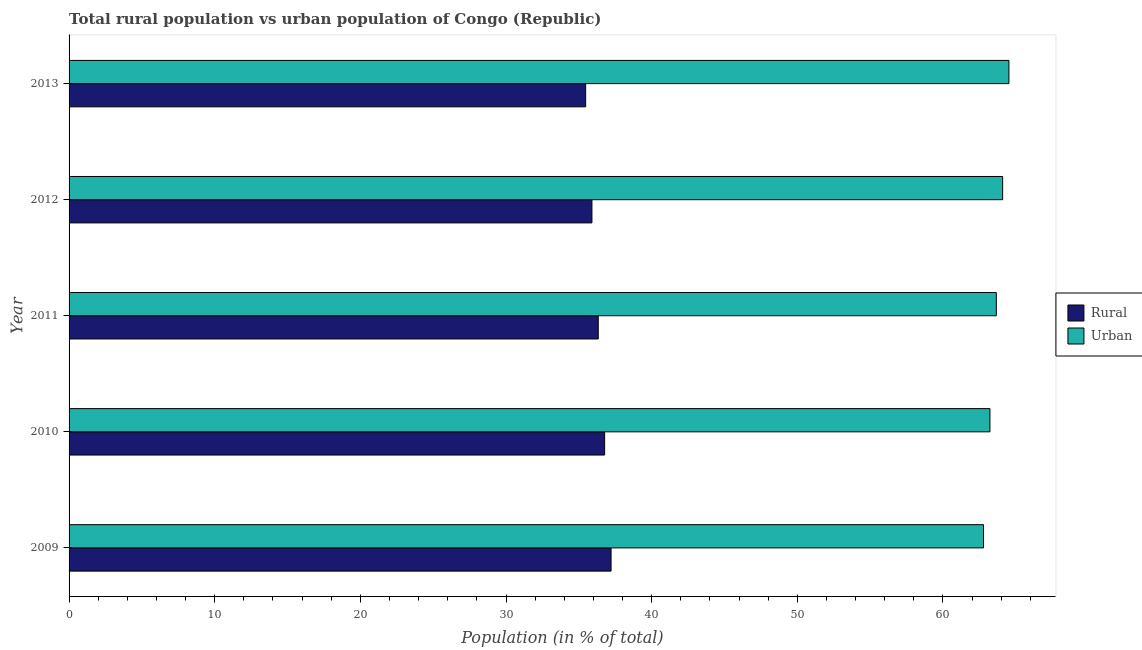How many different coloured bars are there?
Offer a terse response. 2. How many groups of bars are there?
Your answer should be compact. 5. How many bars are there on the 3rd tick from the bottom?
Keep it short and to the point. 2. What is the label of the 4th group of bars from the top?
Give a very brief answer. 2010. What is the rural population in 2013?
Your response must be concise. 35.47. Across all years, what is the maximum urban population?
Your response must be concise. 64.53. Across all years, what is the minimum urban population?
Offer a terse response. 62.79. In which year was the urban population maximum?
Make the answer very short. 2013. What is the total urban population in the graph?
Provide a short and direct response. 318.31. What is the difference between the urban population in 2009 and that in 2011?
Make the answer very short. -0.88. What is the difference between the urban population in 2009 and the rural population in 2013?
Your answer should be very brief. 27.32. What is the average rural population per year?
Give a very brief answer. 36.34. In the year 2012, what is the difference between the urban population and rural population?
Ensure brevity in your answer.  28.2. In how many years, is the urban population greater than 2 %?
Your answer should be very brief. 5. What is the ratio of the rural population in 2010 to that in 2013?
Your response must be concise. 1.04. Is the rural population in 2009 less than that in 2010?
Your answer should be compact. No. Is the difference between the rural population in 2009 and 2010 greater than the difference between the urban population in 2009 and 2010?
Your answer should be very brief. Yes. What is the difference between the highest and the second highest urban population?
Offer a very short reply. 0.43. What does the 1st bar from the top in 2013 represents?
Make the answer very short. Urban. What does the 2nd bar from the bottom in 2010 represents?
Make the answer very short. Urban. How many bars are there?
Give a very brief answer. 10. What is the difference between two consecutive major ticks on the X-axis?
Offer a very short reply. 10. Does the graph contain any zero values?
Your answer should be very brief. No. Does the graph contain grids?
Your answer should be very brief. No. How many legend labels are there?
Your answer should be compact. 2. How are the legend labels stacked?
Offer a very short reply. Vertical. What is the title of the graph?
Make the answer very short. Total rural population vs urban population of Congo (Republic). Does "Non-pregnant women" appear as one of the legend labels in the graph?
Your answer should be very brief. No. What is the label or title of the X-axis?
Give a very brief answer. Population (in % of total). What is the label or title of the Y-axis?
Keep it short and to the point. Year. What is the Population (in % of total) in Rural in 2009?
Ensure brevity in your answer.  37.21. What is the Population (in % of total) in Urban in 2009?
Offer a very short reply. 62.79. What is the Population (in % of total) of Rural in 2010?
Your answer should be very brief. 36.77. What is the Population (in % of total) of Urban in 2010?
Provide a succinct answer. 63.23. What is the Population (in % of total) of Rural in 2011?
Your answer should be very brief. 36.33. What is the Population (in % of total) in Urban in 2011?
Offer a terse response. 63.67. What is the Population (in % of total) of Rural in 2012?
Make the answer very short. 35.9. What is the Population (in % of total) in Urban in 2012?
Your answer should be very brief. 64.1. What is the Population (in % of total) in Rural in 2013?
Your answer should be compact. 35.47. What is the Population (in % of total) in Urban in 2013?
Provide a succinct answer. 64.53. Across all years, what is the maximum Population (in % of total) of Rural?
Offer a terse response. 37.21. Across all years, what is the maximum Population (in % of total) of Urban?
Ensure brevity in your answer.  64.53. Across all years, what is the minimum Population (in % of total) of Rural?
Ensure brevity in your answer.  35.47. Across all years, what is the minimum Population (in % of total) in Urban?
Offer a terse response. 62.79. What is the total Population (in % of total) in Rural in the graph?
Offer a very short reply. 181.69. What is the total Population (in % of total) in Urban in the graph?
Offer a very short reply. 318.31. What is the difference between the Population (in % of total) of Rural in 2009 and that in 2010?
Ensure brevity in your answer.  0.44. What is the difference between the Population (in % of total) in Urban in 2009 and that in 2010?
Offer a terse response. -0.44. What is the difference between the Population (in % of total) of Urban in 2009 and that in 2011?
Your response must be concise. -0.88. What is the difference between the Population (in % of total) in Rural in 2009 and that in 2012?
Your answer should be very brief. 1.31. What is the difference between the Population (in % of total) of Urban in 2009 and that in 2012?
Your answer should be very brief. -1.31. What is the difference between the Population (in % of total) of Rural in 2009 and that in 2013?
Your answer should be very brief. 1.75. What is the difference between the Population (in % of total) in Urban in 2009 and that in 2013?
Offer a terse response. -1.75. What is the difference between the Population (in % of total) of Rural in 2010 and that in 2011?
Ensure brevity in your answer.  0.44. What is the difference between the Population (in % of total) of Urban in 2010 and that in 2011?
Ensure brevity in your answer.  -0.44. What is the difference between the Population (in % of total) in Rural in 2010 and that in 2012?
Provide a short and direct response. 0.87. What is the difference between the Population (in % of total) of Urban in 2010 and that in 2012?
Provide a succinct answer. -0.87. What is the difference between the Population (in % of total) of Rural in 2010 and that in 2013?
Offer a terse response. 1.3. What is the difference between the Population (in % of total) in Urban in 2010 and that in 2013?
Offer a very short reply. -1.3. What is the difference between the Population (in % of total) of Rural in 2011 and that in 2012?
Give a very brief answer. 0.43. What is the difference between the Population (in % of total) of Urban in 2011 and that in 2012?
Keep it short and to the point. -0.43. What is the difference between the Population (in % of total) in Rural in 2011 and that in 2013?
Keep it short and to the point. 0.86. What is the difference between the Population (in % of total) of Urban in 2011 and that in 2013?
Your answer should be very brief. -0.86. What is the difference between the Population (in % of total) of Rural in 2012 and that in 2013?
Give a very brief answer. 0.43. What is the difference between the Population (in % of total) in Urban in 2012 and that in 2013?
Make the answer very short. -0.43. What is the difference between the Population (in % of total) of Rural in 2009 and the Population (in % of total) of Urban in 2010?
Keep it short and to the point. -26.01. What is the difference between the Population (in % of total) of Rural in 2009 and the Population (in % of total) of Urban in 2011?
Your answer should be very brief. -26.45. What is the difference between the Population (in % of total) of Rural in 2009 and the Population (in % of total) of Urban in 2012?
Your answer should be compact. -26.89. What is the difference between the Population (in % of total) of Rural in 2009 and the Population (in % of total) of Urban in 2013?
Ensure brevity in your answer.  -27.32. What is the difference between the Population (in % of total) of Rural in 2010 and the Population (in % of total) of Urban in 2011?
Make the answer very short. -26.89. What is the difference between the Population (in % of total) in Rural in 2010 and the Population (in % of total) in Urban in 2012?
Provide a short and direct response. -27.33. What is the difference between the Population (in % of total) of Rural in 2010 and the Population (in % of total) of Urban in 2013?
Provide a succinct answer. -27.76. What is the difference between the Population (in % of total) of Rural in 2011 and the Population (in % of total) of Urban in 2012?
Keep it short and to the point. -27.77. What is the difference between the Population (in % of total) of Rural in 2011 and the Population (in % of total) of Urban in 2013?
Your response must be concise. -28.2. What is the difference between the Population (in % of total) of Rural in 2012 and the Population (in % of total) of Urban in 2013?
Your answer should be compact. -28.63. What is the average Population (in % of total) of Rural per year?
Offer a very short reply. 36.34. What is the average Population (in % of total) of Urban per year?
Give a very brief answer. 63.66. In the year 2009, what is the difference between the Population (in % of total) of Rural and Population (in % of total) of Urban?
Your answer should be very brief. -25.57. In the year 2010, what is the difference between the Population (in % of total) of Rural and Population (in % of total) of Urban?
Keep it short and to the point. -26.46. In the year 2011, what is the difference between the Population (in % of total) in Rural and Population (in % of total) in Urban?
Make the answer very short. -27.33. In the year 2012, what is the difference between the Population (in % of total) in Rural and Population (in % of total) in Urban?
Your answer should be very brief. -28.2. In the year 2013, what is the difference between the Population (in % of total) of Rural and Population (in % of total) of Urban?
Keep it short and to the point. -29.06. What is the ratio of the Population (in % of total) in Rural in 2009 to that in 2011?
Offer a terse response. 1.02. What is the ratio of the Population (in % of total) in Urban in 2009 to that in 2011?
Make the answer very short. 0.99. What is the ratio of the Population (in % of total) of Rural in 2009 to that in 2012?
Your answer should be very brief. 1.04. What is the ratio of the Population (in % of total) in Urban in 2009 to that in 2012?
Your answer should be compact. 0.98. What is the ratio of the Population (in % of total) in Rural in 2009 to that in 2013?
Make the answer very short. 1.05. What is the ratio of the Population (in % of total) in Urban in 2009 to that in 2013?
Offer a very short reply. 0.97. What is the ratio of the Population (in % of total) of Rural in 2010 to that in 2011?
Your answer should be very brief. 1.01. What is the ratio of the Population (in % of total) of Rural in 2010 to that in 2012?
Offer a terse response. 1.02. What is the ratio of the Population (in % of total) in Urban in 2010 to that in 2012?
Offer a terse response. 0.99. What is the ratio of the Population (in % of total) of Rural in 2010 to that in 2013?
Your response must be concise. 1.04. What is the ratio of the Population (in % of total) in Urban in 2010 to that in 2013?
Make the answer very short. 0.98. What is the ratio of the Population (in % of total) in Rural in 2011 to that in 2012?
Ensure brevity in your answer.  1.01. What is the ratio of the Population (in % of total) of Urban in 2011 to that in 2012?
Ensure brevity in your answer.  0.99. What is the ratio of the Population (in % of total) of Rural in 2011 to that in 2013?
Ensure brevity in your answer.  1.02. What is the ratio of the Population (in % of total) in Urban in 2011 to that in 2013?
Offer a terse response. 0.99. What is the ratio of the Population (in % of total) in Rural in 2012 to that in 2013?
Provide a succinct answer. 1.01. What is the difference between the highest and the second highest Population (in % of total) of Rural?
Provide a short and direct response. 0.44. What is the difference between the highest and the second highest Population (in % of total) of Urban?
Provide a succinct answer. 0.43. What is the difference between the highest and the lowest Population (in % of total) of Rural?
Offer a very short reply. 1.75. What is the difference between the highest and the lowest Population (in % of total) of Urban?
Ensure brevity in your answer.  1.75. 